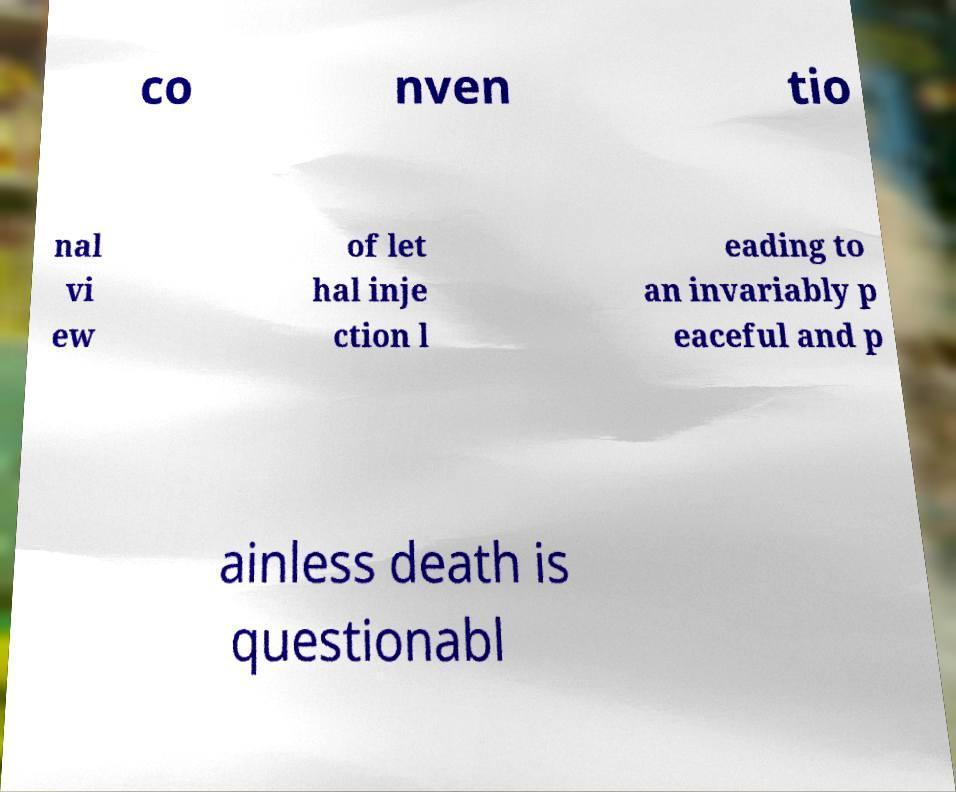Could you extract and type out the text from this image? co nven tio nal vi ew of let hal inje ction l eading to an invariably p eaceful and p ainless death is questionabl 